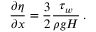<formula> <loc_0><loc_0><loc_500><loc_500>\frac { \partial \eta } { \partial x } = \frac { 3 } { 2 } \frac { \tau _ { w } } { \rho g H } \, .</formula> 